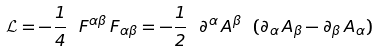<formula> <loc_0><loc_0><loc_500><loc_500>\mathcal { L } = - \frac { 1 } { 4 } \ F ^ { \alpha \beta } \, F _ { \alpha \beta } = - \frac { 1 } { 2 } \ \partial ^ { \alpha } \, A ^ { \beta } \ ( \partial _ { \alpha } \, A _ { \beta } - \partial _ { \beta } \, A _ { \alpha } )</formula> 